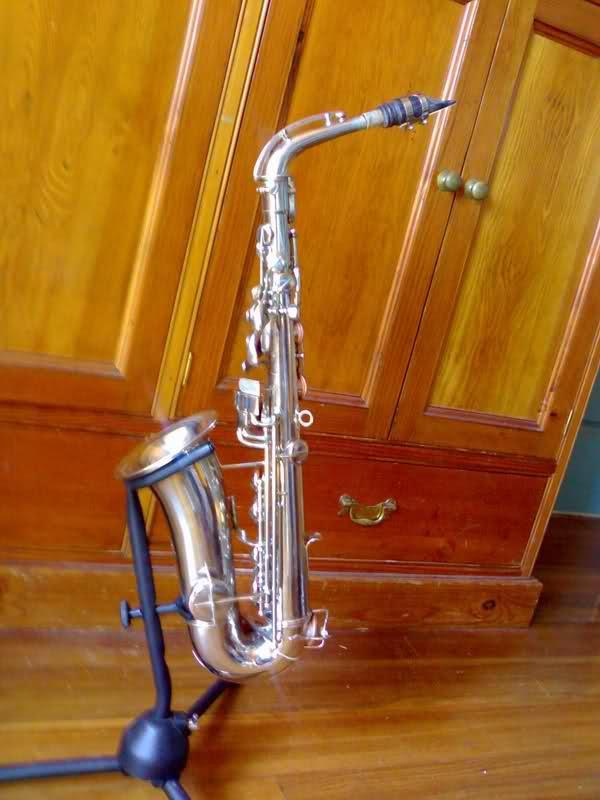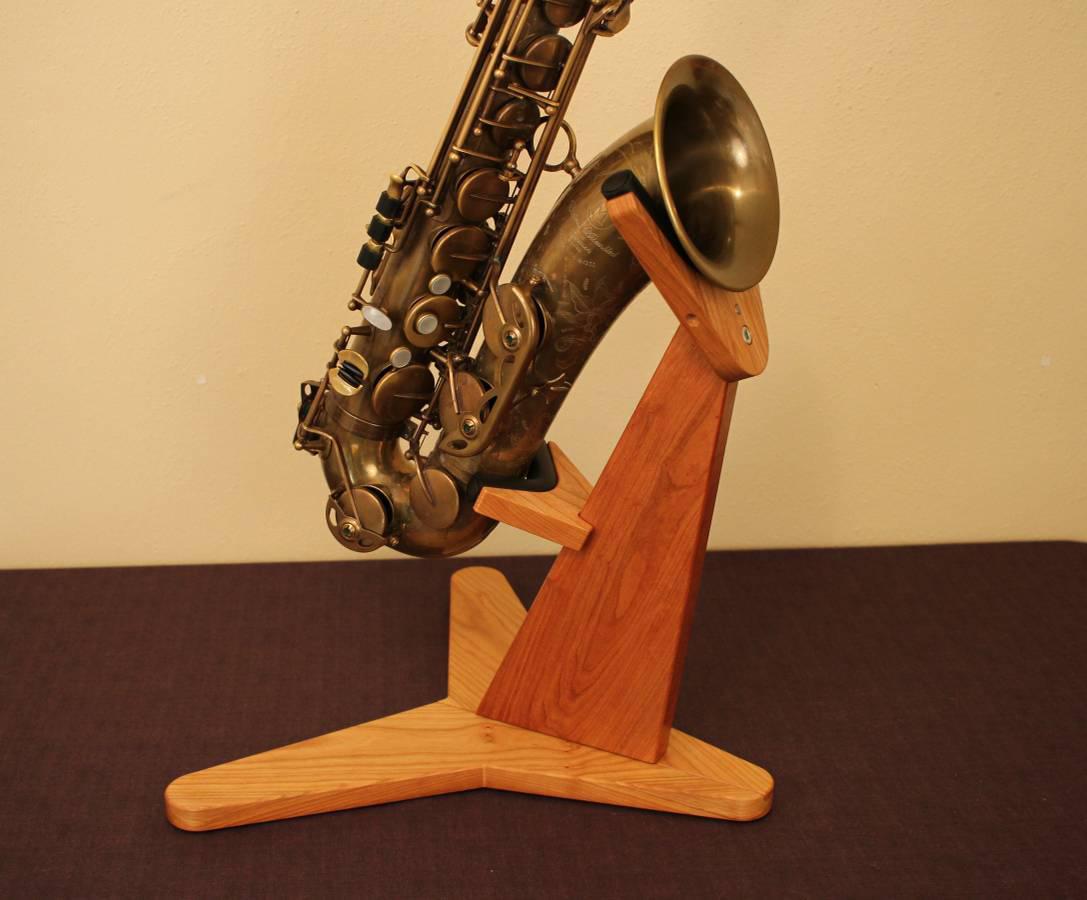The first image is the image on the left, the second image is the image on the right. For the images shown, is this caption "One of images contains a saxophone with wood in the background." true? Answer yes or no. Yes. 